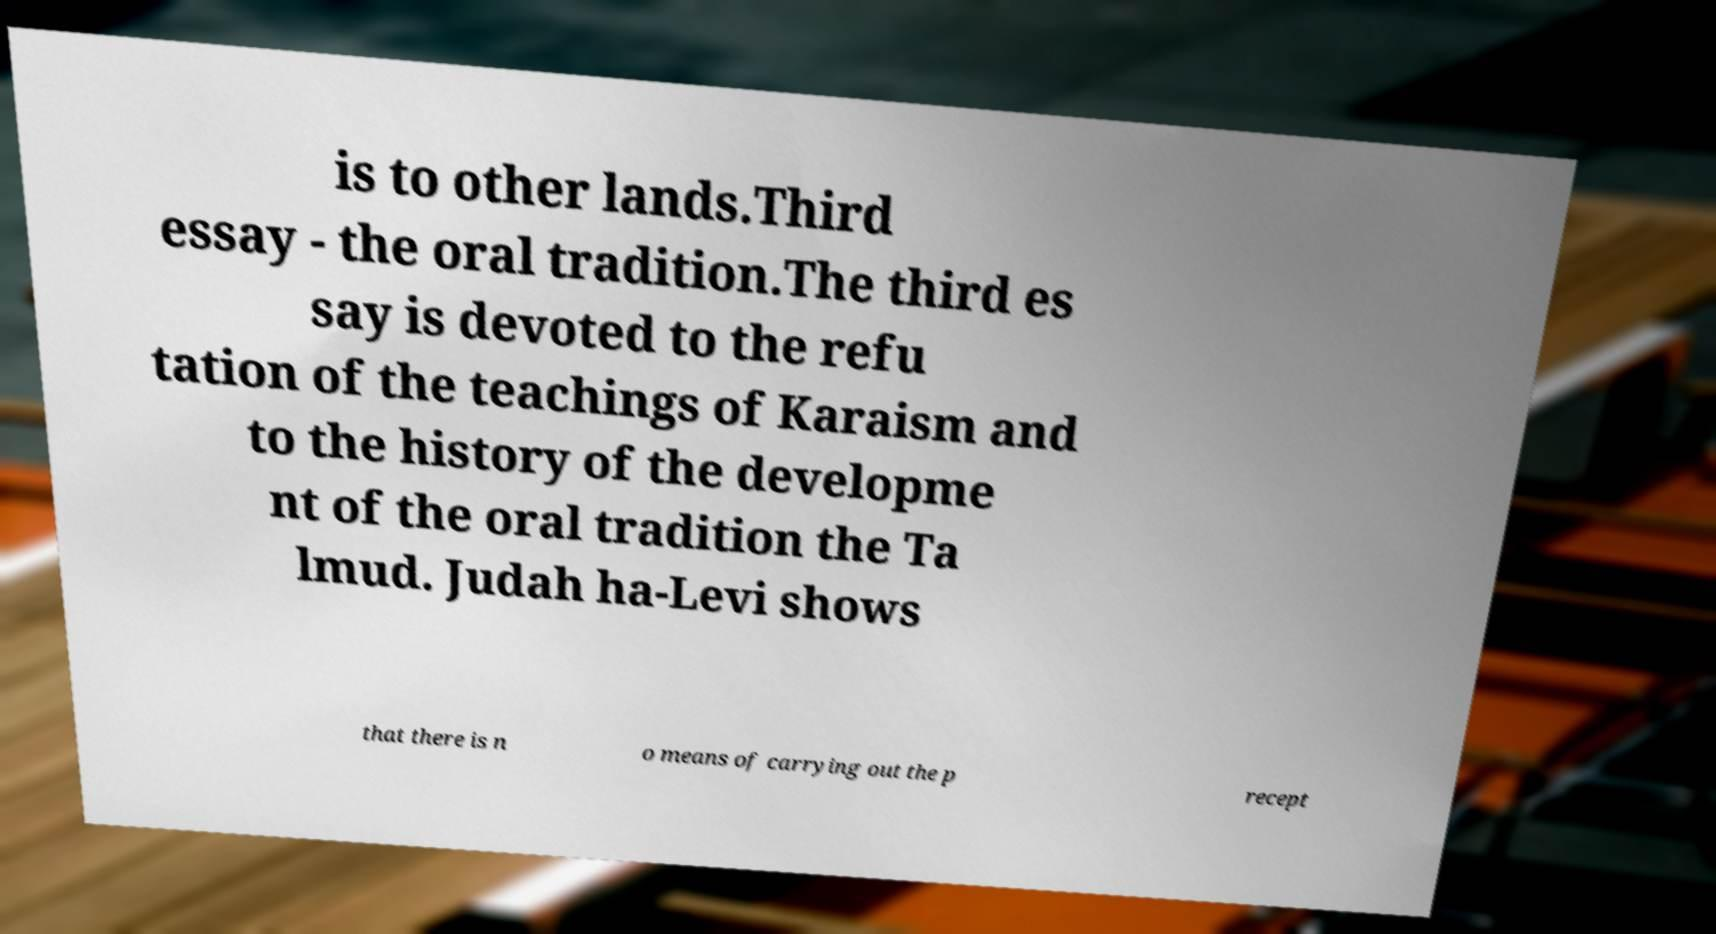Can you read and provide the text displayed in the image?This photo seems to have some interesting text. Can you extract and type it out for me? is to other lands.Third essay - the oral tradition.The third es say is devoted to the refu tation of the teachings of Karaism and to the history of the developme nt of the oral tradition the Ta lmud. Judah ha-Levi shows that there is n o means of carrying out the p recept 